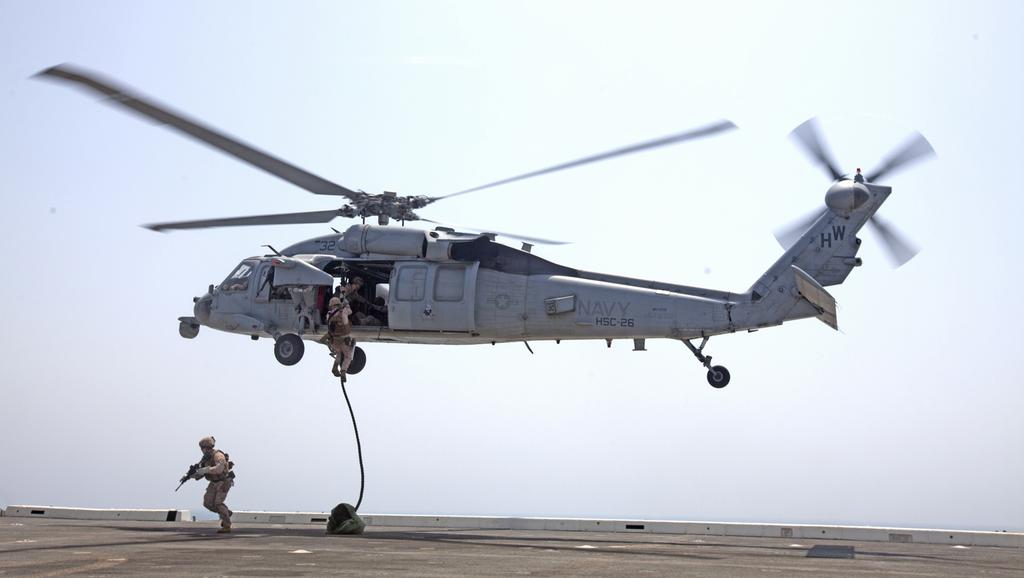What is the main subject of the image? The main subject of the image is a helicopter. Where is the helicopter located in the image? The helicopter is in the air in the image. Can you see any people in the image? Yes, there are people visible in the image. What is visible in the background of the image? The sky is visible in the background of the image. What type of support does the father provide in the image? There is no father present in the image, and therefore no support can be provided. 